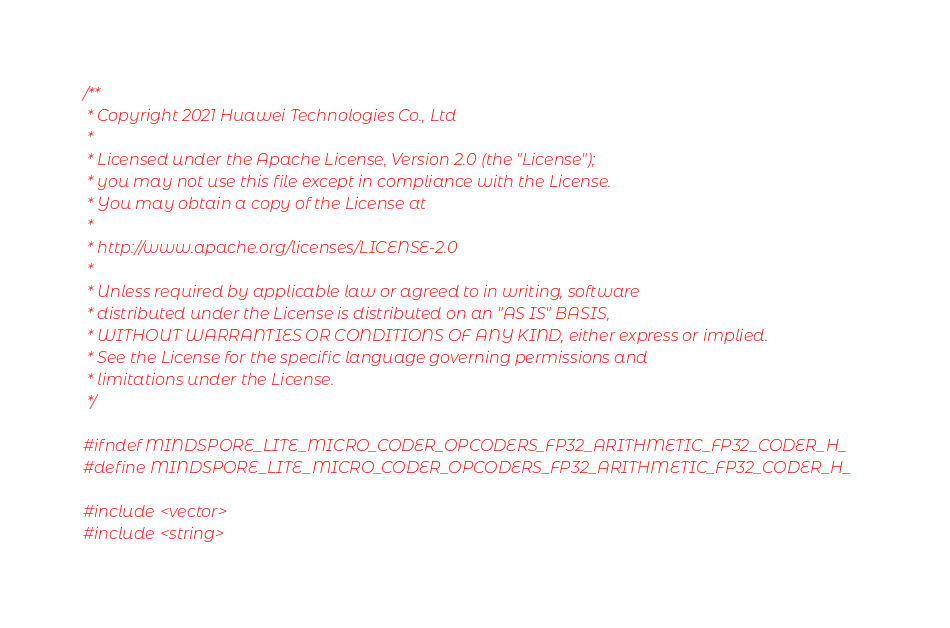Convert code to text. <code><loc_0><loc_0><loc_500><loc_500><_C_>/**
 * Copyright 2021 Huawei Technologies Co., Ltd
 *
 * Licensed under the Apache License, Version 2.0 (the "License");
 * you may not use this file except in compliance with the License.
 * You may obtain a copy of the License at
 *
 * http://www.apache.org/licenses/LICENSE-2.0
 *
 * Unless required by applicable law or agreed to in writing, software
 * distributed under the License is distributed on an "AS IS" BASIS,
 * WITHOUT WARRANTIES OR CONDITIONS OF ANY KIND, either express or implied.
 * See the License for the specific language governing permissions and
 * limitations under the License.
 */

#ifndef MINDSPORE_LITE_MICRO_CODER_OPCODERS_FP32_ARITHMETIC_FP32_CODER_H_
#define MINDSPORE_LITE_MICRO_CODER_OPCODERS_FP32_ARITHMETIC_FP32_CODER_H_

#include <vector>
#include <string></code> 